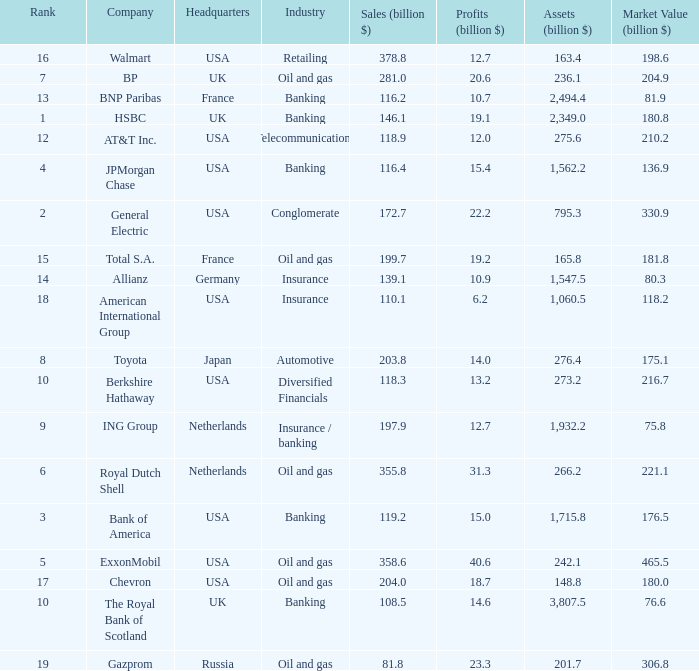What are the profits in billions for Berkshire Hathaway?  13.2. 